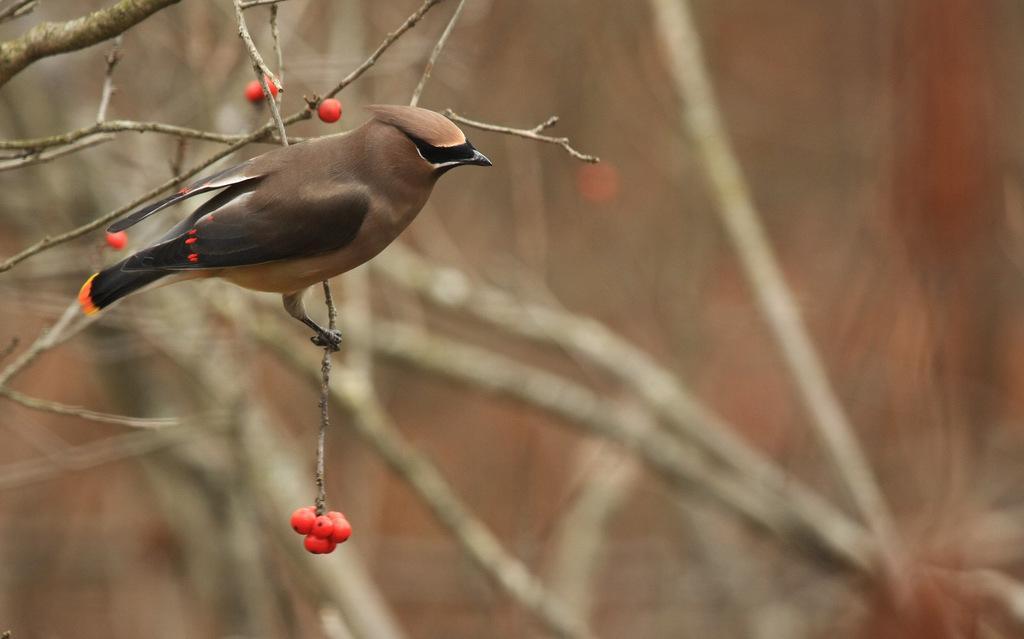Can you describe this image briefly? In this image I can see a bird which is brown, black, orange, red and white in color on the tree branch. I can see few fruits which are orange in color to the tree and the blurry background. 